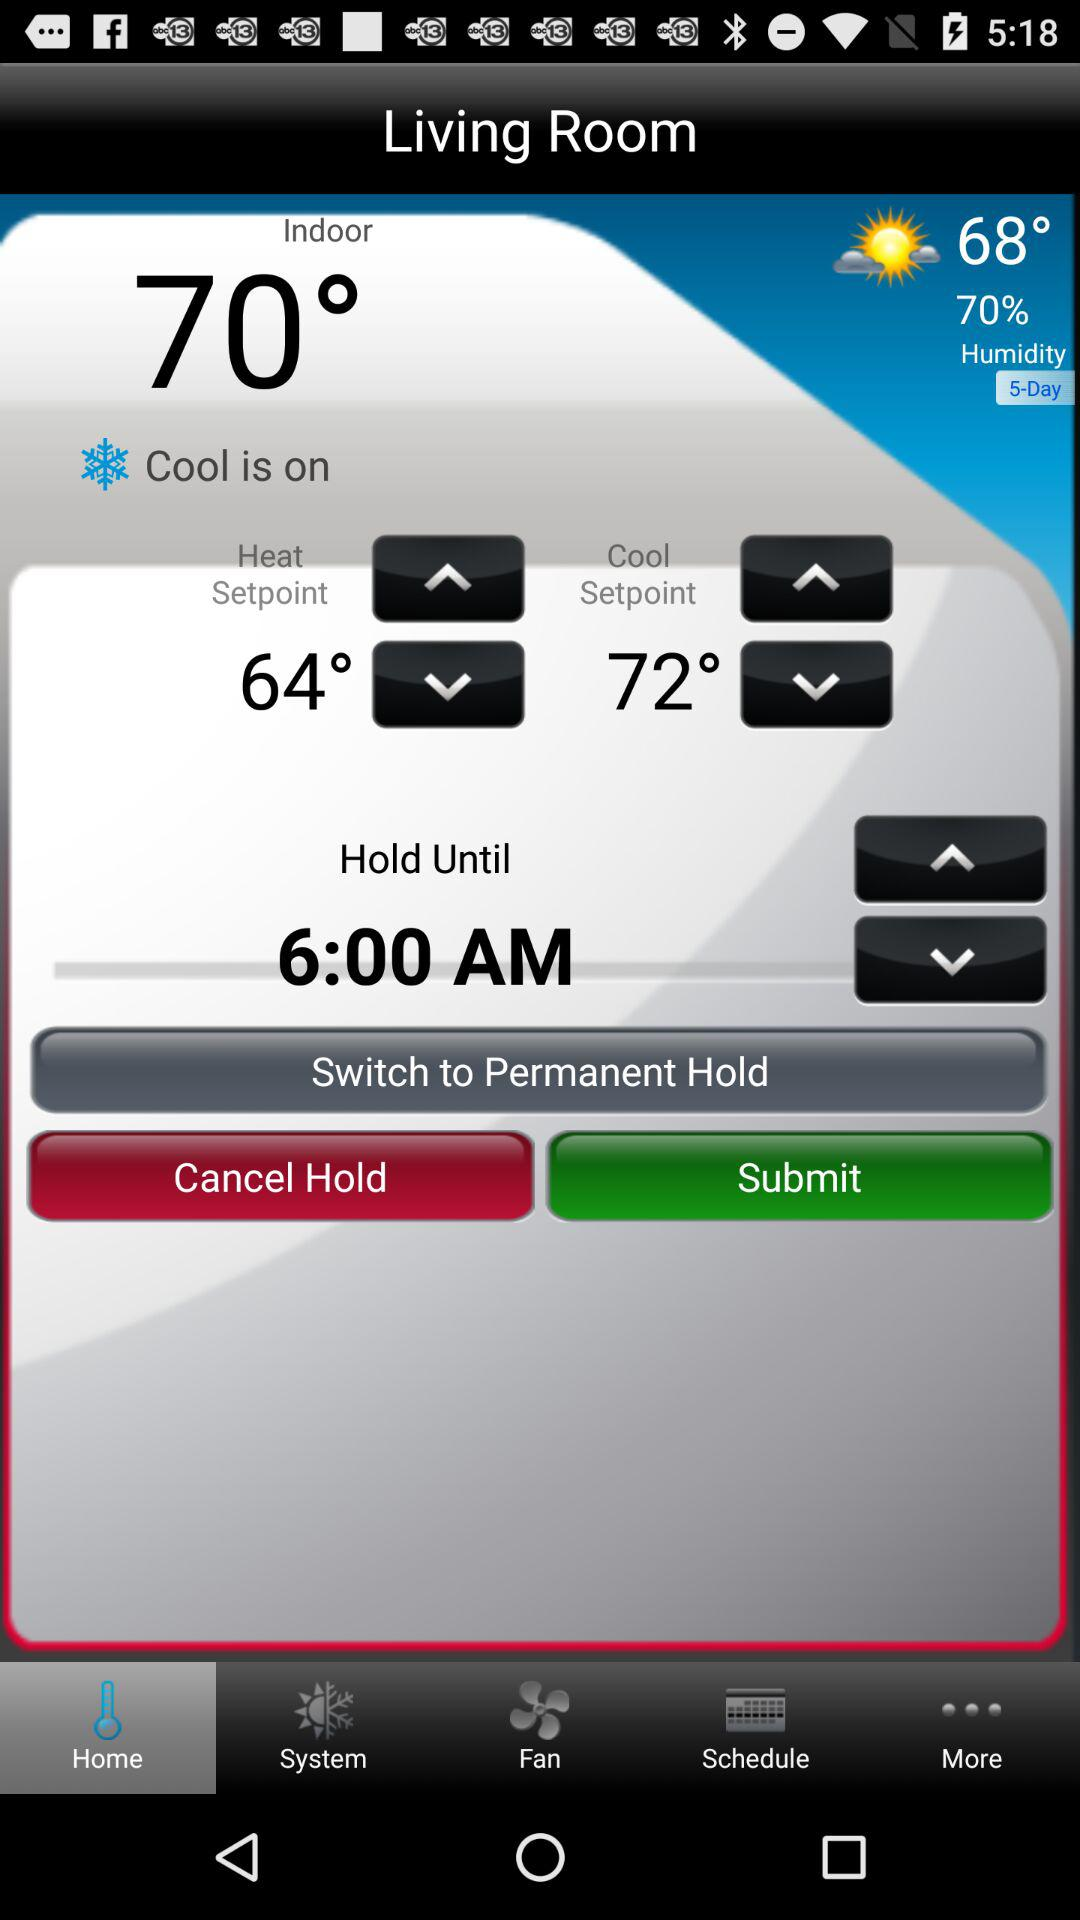How long will the temperature be maintained? The temperature will be maintained until 6:00 AM. 